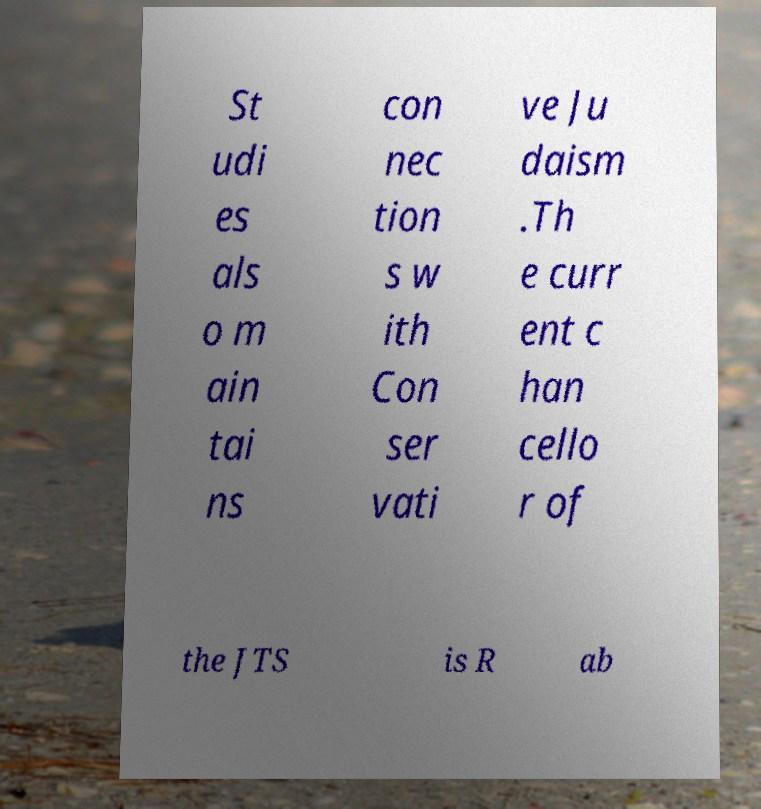I need the written content from this picture converted into text. Can you do that? St udi es als o m ain tai ns con nec tion s w ith Con ser vati ve Ju daism .Th e curr ent c han cello r of the JTS is R ab 